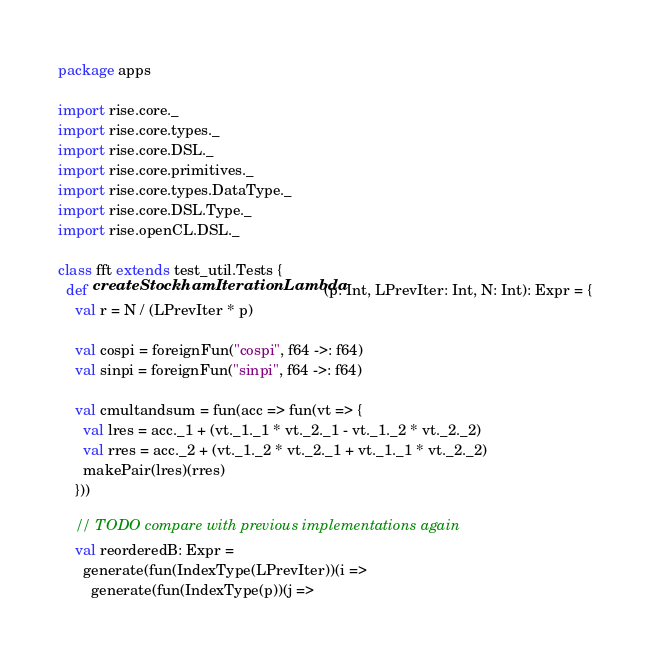Convert code to text. <code><loc_0><loc_0><loc_500><loc_500><_Scala_>package apps

import rise.core._
import rise.core.types._
import rise.core.DSL._
import rise.core.primitives._
import rise.core.types.DataType._
import rise.core.DSL.Type._
import rise.openCL.DSL._

class fft extends test_util.Tests {
  def createStockhamIterationLambda(p: Int, LPrevIter: Int, N: Int): Expr = {
    val r = N / (LPrevIter * p)

    val cospi = foreignFun("cospi", f64 ->: f64)
    val sinpi = foreignFun("sinpi", f64 ->: f64)

    val cmultandsum = fun(acc => fun(vt => {
      val lres = acc._1 + (vt._1._1 * vt._2._1 - vt._1._2 * vt._2._2)
      val rres = acc._2 + (vt._1._2 * vt._2._1 + vt._1._1 * vt._2._2)
      makePair(lres)(rres)
    }))

    // TODO compare with previous implementations again
    val reorderedB: Expr =
      generate(fun(IndexType(LPrevIter))(i =>
        generate(fun(IndexType(p))(j =></code> 